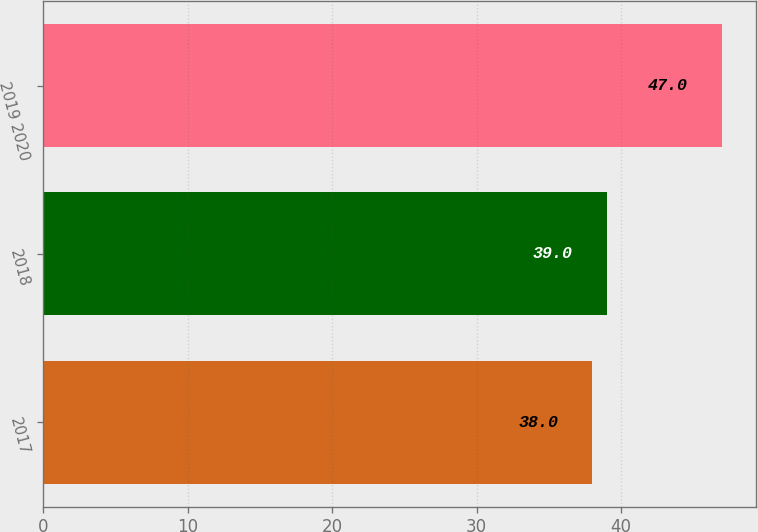<chart> <loc_0><loc_0><loc_500><loc_500><bar_chart><fcel>2017<fcel>2018<fcel>2019 2020<nl><fcel>38<fcel>39<fcel>47<nl></chart> 